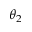Convert formula to latex. <formula><loc_0><loc_0><loc_500><loc_500>\theta _ { 2 }</formula> 